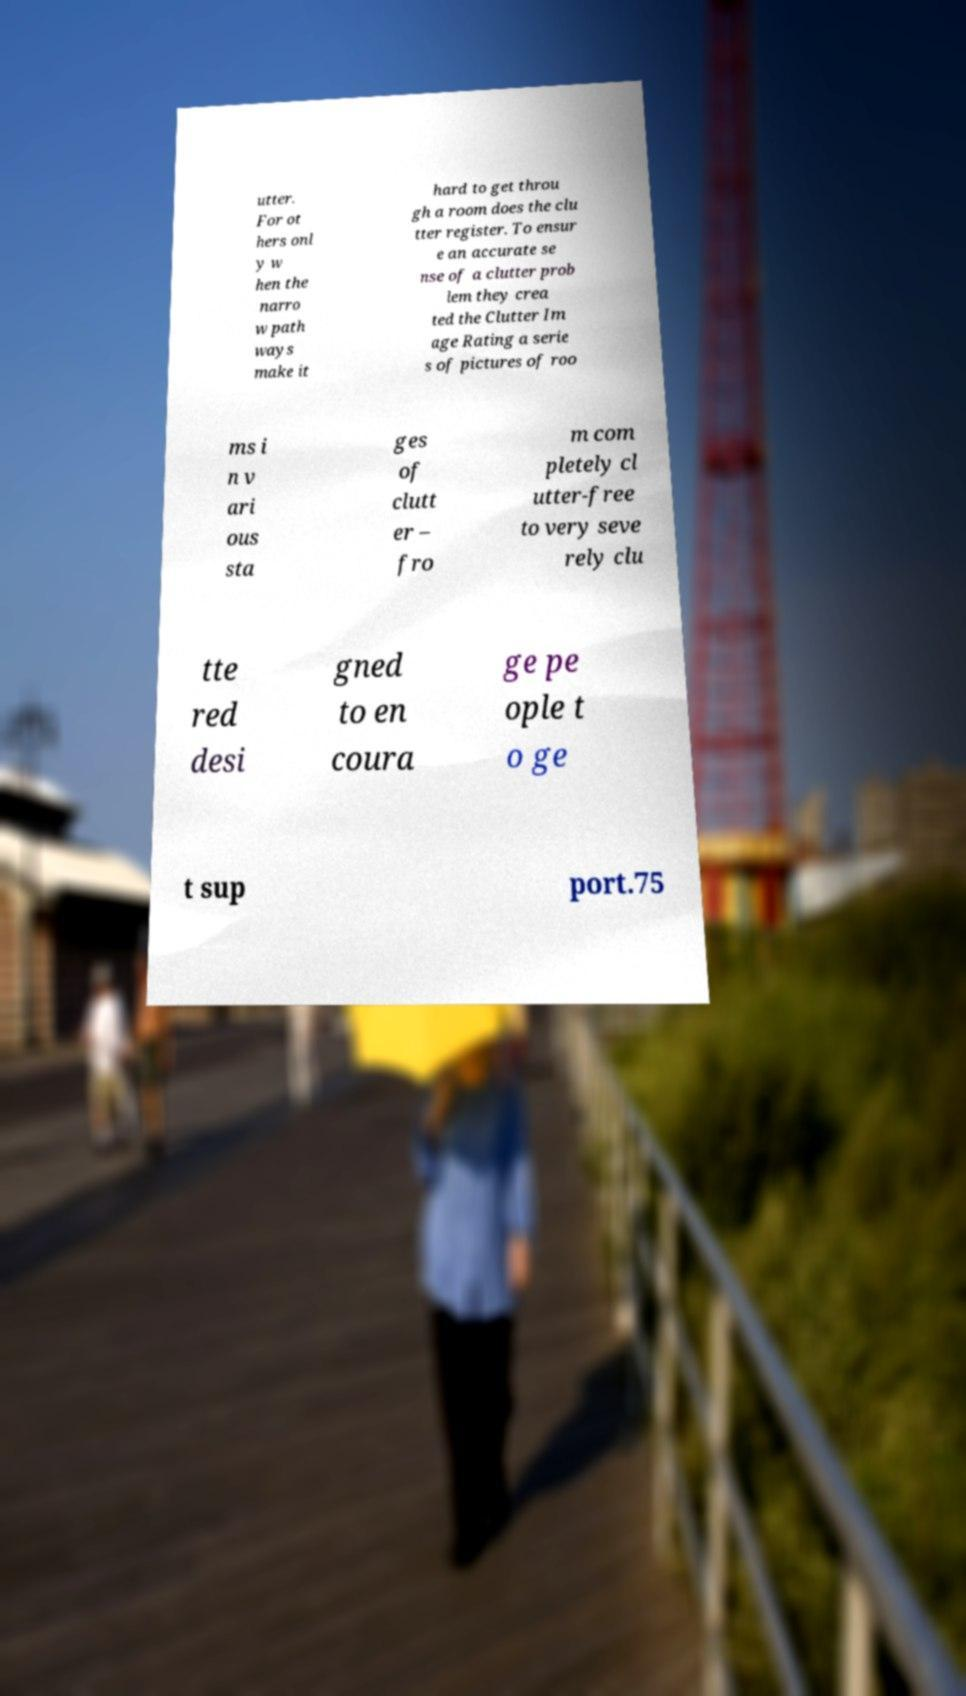Please read and relay the text visible in this image. What does it say? utter. For ot hers onl y w hen the narro w path ways make it hard to get throu gh a room does the clu tter register. To ensur e an accurate se nse of a clutter prob lem they crea ted the Clutter Im age Rating a serie s of pictures of roo ms i n v ari ous sta ges of clutt er – fro m com pletely cl utter-free to very seve rely clu tte red desi gned to en coura ge pe ople t o ge t sup port.75 